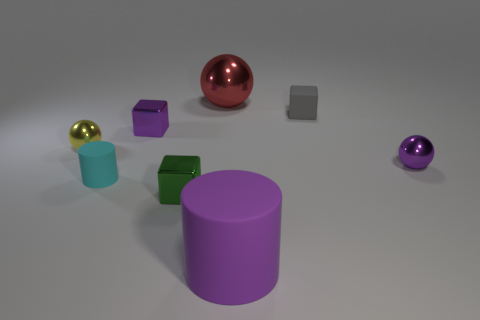Are there more tiny yellow things that are on the left side of the red thing than cylinders that are on the left side of the cyan cylinder?
Give a very brief answer. Yes. The small rubber thing that is the same shape as the green metal object is what color?
Offer a terse response. Gray. There is a yellow thing; is its shape the same as the big thing to the right of the big red thing?
Offer a terse response. No. What number of other things are the same material as the tiny purple block?
Provide a short and direct response. 4. There is a small matte cube; does it have the same color as the block in front of the tiny purple metallic sphere?
Your response must be concise. No. There is a purple object to the right of the large cylinder; what material is it?
Offer a very short reply. Metal. Are there any rubber cylinders that have the same color as the matte cube?
Make the answer very short. No. There is a metal cube that is the same size as the green shiny object; what color is it?
Your answer should be very brief. Purple. How many tiny things are matte blocks or green metal objects?
Offer a terse response. 2. Is the number of small balls left of the tiny yellow metal thing the same as the number of green cubes that are behind the green shiny thing?
Your answer should be compact. Yes. 